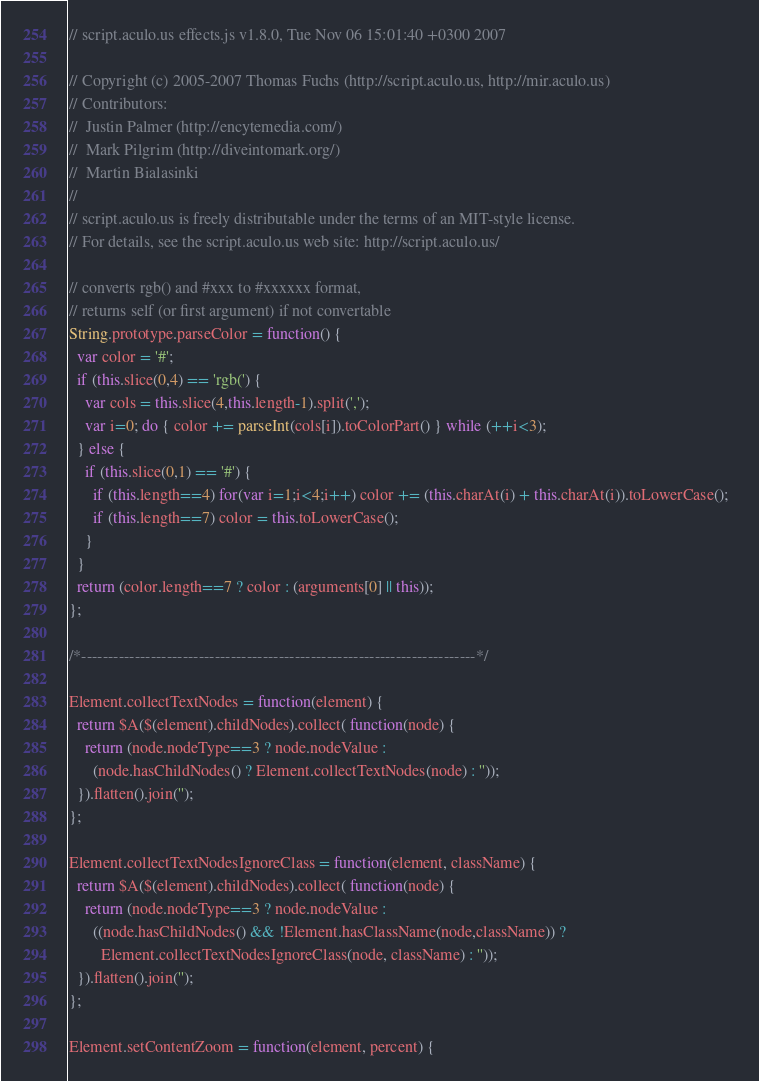Convert code to text. <code><loc_0><loc_0><loc_500><loc_500><_JavaScript_>// script.aculo.us effects.js v1.8.0, Tue Nov 06 15:01:40 +0300 2007

// Copyright (c) 2005-2007 Thomas Fuchs (http://script.aculo.us, http://mir.aculo.us)
// Contributors:
//  Justin Palmer (http://encytemedia.com/)
//  Mark Pilgrim (http://diveintomark.org/)
//  Martin Bialasinki
// 
// script.aculo.us is freely distributable under the terms of an MIT-style license.
// For details, see the script.aculo.us web site: http://script.aculo.us/ 

// converts rgb() and #xxx to #xxxxxx format,  
// returns self (or first argument) if not convertable  
String.prototype.parseColor = function() {  
  var color = '#';
  if (this.slice(0,4) == 'rgb(') {  
    var cols = this.slice(4,this.length-1).split(',');  
    var i=0; do { color += parseInt(cols[i]).toColorPart() } while (++i<3);  
  } else {  
    if (this.slice(0,1) == '#') {  
      if (this.length==4) for(var i=1;i<4;i++) color += (this.charAt(i) + this.charAt(i)).toLowerCase();  
      if (this.length==7) color = this.toLowerCase();  
    }  
  }  
  return (color.length==7 ? color : (arguments[0] || this));  
};

/*--------------------------------------------------------------------------*/

Element.collectTextNodes = function(element) {  
  return $A($(element).childNodes).collect( function(node) {
    return (node.nodeType==3 ? node.nodeValue : 
      (node.hasChildNodes() ? Element.collectTextNodes(node) : ''));
  }).flatten().join('');
};

Element.collectTextNodesIgnoreClass = function(element, className) {  
  return $A($(element).childNodes).collect( function(node) {
    return (node.nodeType==3 ? node.nodeValue : 
      ((node.hasChildNodes() && !Element.hasClassName(node,className)) ? 
        Element.collectTextNodesIgnoreClass(node, className) : ''));
  }).flatten().join('');
};

Element.setContentZoom = function(element, percent) {</code> 